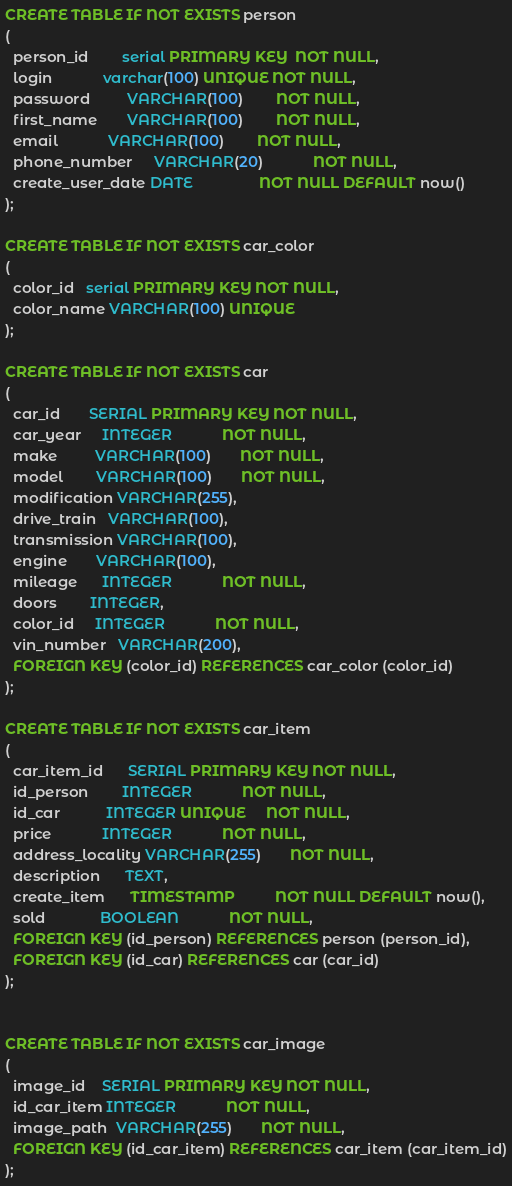<code> <loc_0><loc_0><loc_500><loc_500><_SQL_>CREATE TABLE IF NOT EXISTS person
(
  person_id        serial PRIMARY KEY  NOT NULL,
  login            varchar(100) UNIQUE NOT NULL,
  password         VARCHAR(100)        NOT NULL,
  first_name       VARCHAR(100)        NOT NULL,
  email            VARCHAR(100)        NOT NULL,
  phone_number     VARCHAR(20)            NOT NULL,
  create_user_date DATE                NOT NULL DEFAULT now()
);

CREATE TABLE IF NOT EXISTS car_color
(
  color_id   serial PRIMARY KEY NOT NULL,
  color_name VARCHAR(100) UNIQUE
);

CREATE TABLE IF NOT EXISTS car
(
  car_id       SERIAL PRIMARY KEY NOT NULL,
  car_year     INTEGER            NOT NULL,
  make         VARCHAR(100)       NOT NULL,
  model        VARCHAR(100)       NOT NULL,
  modification VARCHAR(255),
  drive_train   VARCHAR(100),
  transmission VARCHAR(100),
  engine       VARCHAR(100),
  mileage      INTEGER            NOT NULL,
  doors        INTEGER,
  color_id     INTEGER            NOT NULL,
  vin_number   VARCHAR(200),
  FOREIGN KEY (color_id) REFERENCES car_color (color_id)
);

CREATE TABLE IF NOT EXISTS car_item
(
  car_item_id      SERIAL PRIMARY KEY NOT NULL,
  id_person        INTEGER            NOT NULL,
  id_car           INTEGER UNIQUE     NOT NULL,
  price            INTEGER            NOT NULL,
  address_locality VARCHAR(255)       NOT NULL,
  description      TEXT,
  create_item      TIMESTAMP          NOT NULL DEFAULT now(),
  sold             BOOLEAN            NOT NULL,
  FOREIGN KEY (id_person) REFERENCES person (person_id),
  FOREIGN KEY (id_car) REFERENCES car (car_id)
);


CREATE TABLE IF NOT EXISTS car_image
(
  image_id    SERIAL PRIMARY KEY NOT NULL,
  id_car_item INTEGER            NOT NULL,
  image_path  VARCHAR(255)       NOT NULL,
  FOREIGN KEY (id_car_item) REFERENCES car_item (car_item_id)
);

</code> 